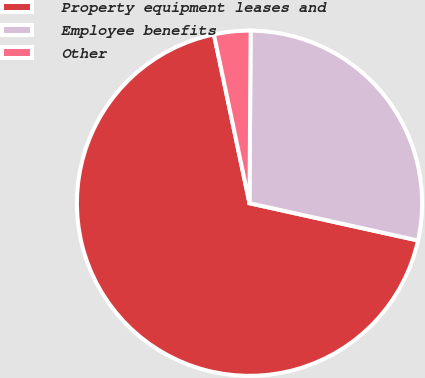<chart> <loc_0><loc_0><loc_500><loc_500><pie_chart><fcel>Property equipment leases and<fcel>Employee benefits<fcel>Other<nl><fcel>68.23%<fcel>28.36%<fcel>3.41%<nl></chart> 